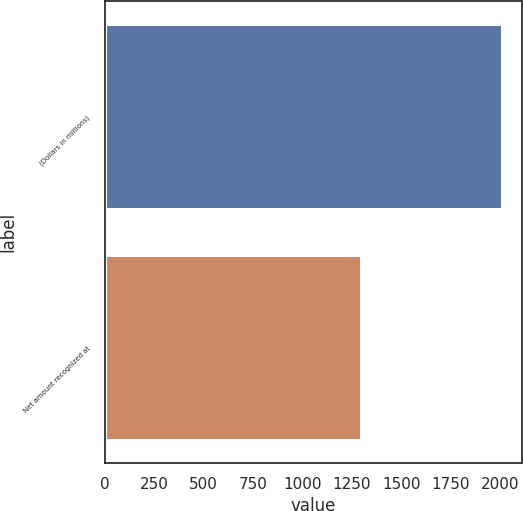<chart> <loc_0><loc_0><loc_500><loc_500><bar_chart><fcel>(Dollars in millions)<fcel>Net amount recognized at<nl><fcel>2008<fcel>1294<nl></chart> 